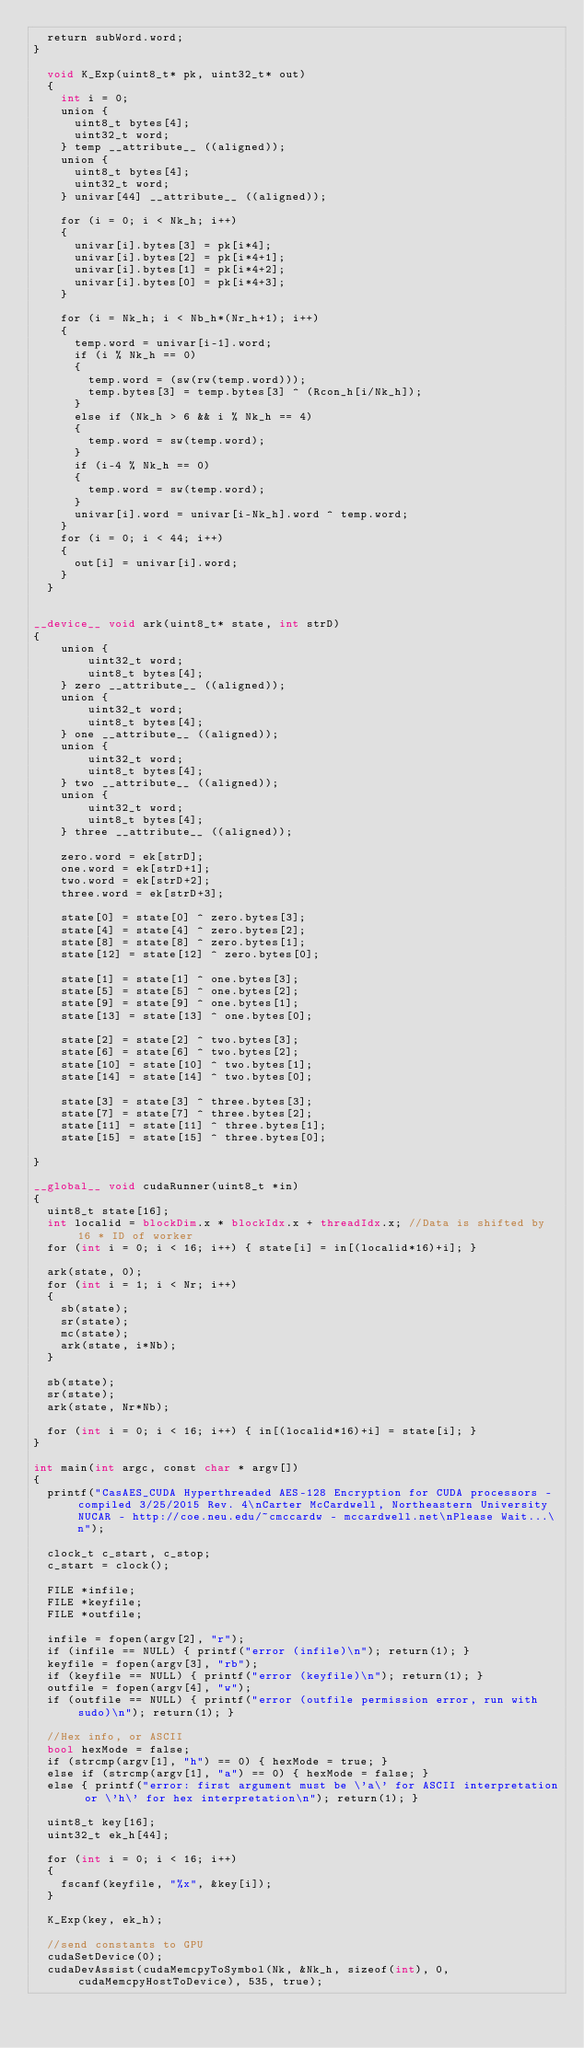Convert code to text. <code><loc_0><loc_0><loc_500><loc_500><_Cuda_>	return subWord.word;
}

	void K_Exp(uint8_t* pk, uint32_t* out)
	{
		int i = 0;
		union {
			uint8_t bytes[4];
			uint32_t word;
		} temp __attribute__ ((aligned));
		union {
			uint8_t bytes[4];
			uint32_t word;
		} univar[44] __attribute__ ((aligned));

		for (i = 0; i < Nk_h; i++)
		{
			univar[i].bytes[3] = pk[i*4];
			univar[i].bytes[2] = pk[i*4+1];
			univar[i].bytes[1] = pk[i*4+2];
			univar[i].bytes[0] = pk[i*4+3];
		}

		for (i = Nk_h; i < Nb_h*(Nr_h+1); i++)
		{
			temp.word = univar[i-1].word;
			if (i % Nk_h == 0)
			{
				temp.word = (sw(rw(temp.word)));
				temp.bytes[3] = temp.bytes[3] ^ (Rcon_h[i/Nk_h]);
			}
			else if (Nk_h > 6 && i % Nk_h == 4)
			{
				temp.word = sw(temp.word);
			}
			if (i-4 % Nk_h == 0)
			{
				temp.word = sw(temp.word);
			}
			univar[i].word = univar[i-Nk_h].word ^ temp.word;
		}
		for (i = 0; i < 44; i++)
		{
			out[i] = univar[i].word;
		}
	}


__device__ void ark(uint8_t* state, int strD)
{
    union {
	    	uint32_t word;
	    	uint8_t bytes[4];
	  } zero __attribute__ ((aligned));
    union {
        uint32_t word;
        uint8_t bytes[4];
    } one __attribute__ ((aligned));
    union {
        uint32_t word;
        uint8_t bytes[4];
    } two __attribute__ ((aligned));
    union {
        uint32_t word;
        uint8_t bytes[4];
    } three __attribute__ ((aligned));

	  zero.word = ek[strD];
	  one.word = ek[strD+1];
	  two.word = ek[strD+2];
	  three.word = ek[strD+3];

    state[0] = state[0] ^ zero.bytes[3];
    state[4] = state[4] ^ zero.bytes[2];
    state[8] = state[8] ^ zero.bytes[1];
    state[12] = state[12] ^ zero.bytes[0];

    state[1] = state[1] ^ one.bytes[3];
    state[5] = state[5] ^ one.bytes[2];
    state[9] = state[9] ^ one.bytes[1];
    state[13] = state[13] ^ one.bytes[0];

    state[2] = state[2] ^ two.bytes[3];
    state[6] = state[6] ^ two.bytes[2];
    state[10] = state[10] ^ two.bytes[1];
    state[14] = state[14] ^ two.bytes[0];

    state[3] = state[3] ^ three.bytes[3];
    state[7] = state[7] ^ three.bytes[2];
    state[11] = state[11] ^ three.bytes[1];
    state[15] = state[15] ^ three.bytes[0];

}

__global__ void cudaRunner(uint8_t *in)
{
	uint8_t state[16];
  int localid = blockDim.x * blockIdx.x + threadIdx.x; //Data is shifted by 16 * ID of worker
  for (int i = 0; i < 16; i++) { state[i] = in[(localid*16)+i]; }

	ark(state, 0);
	for (int i = 1; i < Nr; i++)
	{
		sb(state);
		sr(state);
		mc(state);
		ark(state, i*Nb);
	}

	sb(state);
	sr(state);
	ark(state, Nr*Nb);

	for (int i = 0; i < 16; i++) { in[(localid*16)+i] = state[i]; }
}

int main(int argc, const char * argv[])
{
	printf("CasAES_CUDA Hyperthreaded AES-128 Encryption for CUDA processors - compiled 3/25/2015 Rev. 4\nCarter McCardwell, Northeastern University NUCAR - http://coe.neu.edu/~cmccardw - mccardwell.net\nPlease Wait...\n");

	clock_t c_start, c_stop;
	c_start = clock();

	FILE *infile;
	FILE *keyfile;
	FILE *outfile;

	infile = fopen(argv[2], "r");
	if (infile == NULL) { printf("error (infile)\n"); return(1); }
	keyfile = fopen(argv[3], "rb");
	if (keyfile == NULL) { printf("error (keyfile)\n"); return(1); }
	outfile = fopen(argv[4], "w");
	if (outfile == NULL) { printf("error (outfile permission error, run with sudo)\n"); return(1); }

	//Hex info, or ASCII
	bool hexMode = false;
	if (strcmp(argv[1], "h") == 0) { hexMode = true; }
	else if (strcmp(argv[1], "a") == 0) { hexMode = false; }
	else { printf("error: first argument must be \'a\' for ASCII interpretation or \'h\' for hex interpretation\n"); return(1); }

	uint8_t key[16];
	uint32_t ek_h[44];

	for (int i = 0; i < 16; i++)
	{
		fscanf(keyfile, "%x", &key[i]);
	}

	K_Exp(key, ek_h);

	//send constants to GPU
	cudaSetDevice(0);
	cudaDevAssist(cudaMemcpyToSymbol(Nk, &Nk_h, sizeof(int), 0, cudaMemcpyHostToDevice), 535, true);</code> 